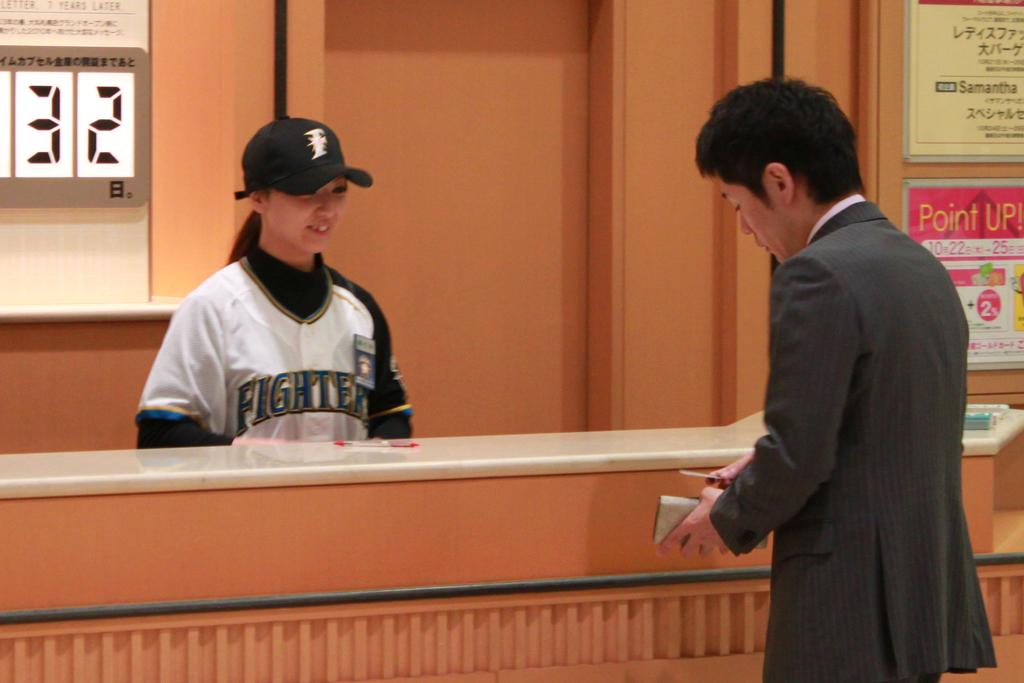<image>
Summarize the visual content of the image. A girl wearing a fighters jersey smiling at a man 